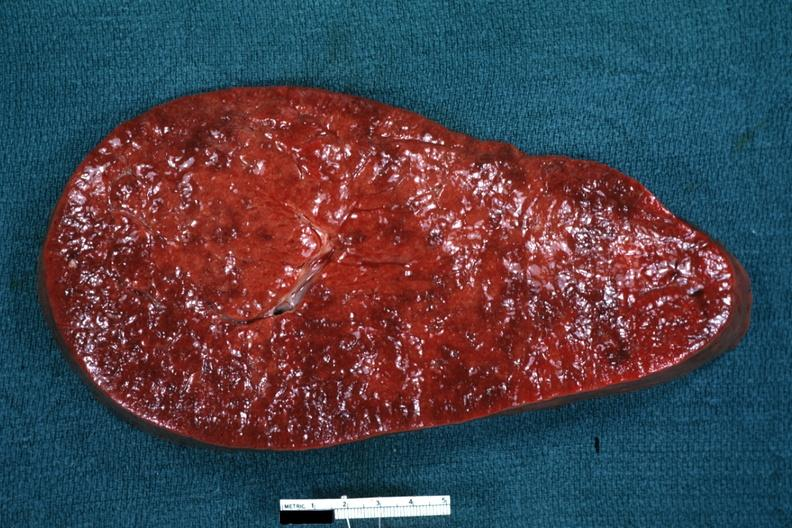how does this image show enlarged spleen?
Answer the question using a single word or phrase. With rather obvious infiltrate 